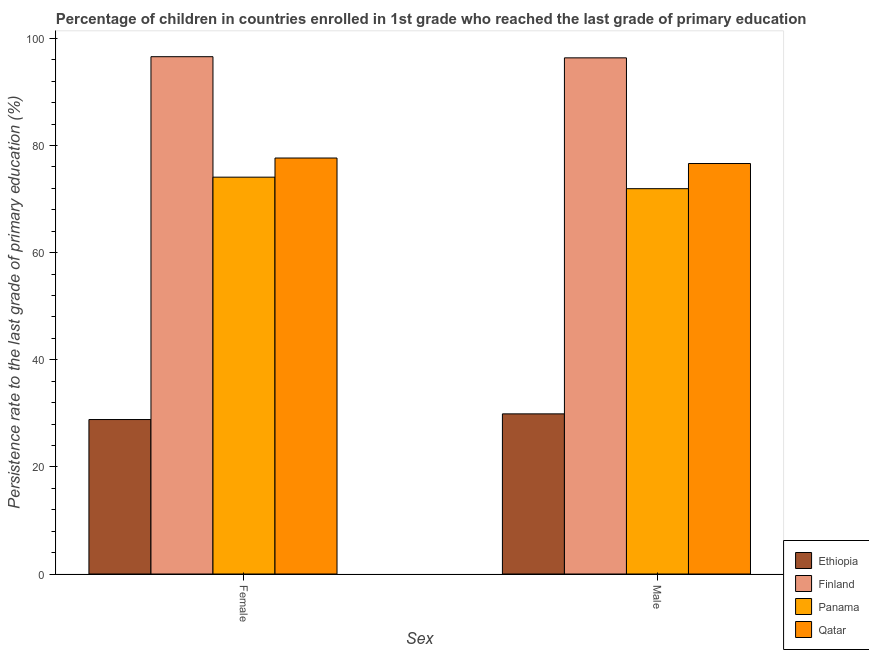Are the number of bars per tick equal to the number of legend labels?
Offer a very short reply. Yes. Are the number of bars on each tick of the X-axis equal?
Your answer should be compact. Yes. What is the label of the 2nd group of bars from the left?
Keep it short and to the point. Male. What is the persistence rate of female students in Finland?
Your answer should be compact. 96.59. Across all countries, what is the maximum persistence rate of female students?
Your answer should be very brief. 96.59. Across all countries, what is the minimum persistence rate of male students?
Offer a very short reply. 29.9. In which country was the persistence rate of male students maximum?
Offer a terse response. Finland. In which country was the persistence rate of male students minimum?
Your response must be concise. Ethiopia. What is the total persistence rate of female students in the graph?
Provide a short and direct response. 277.21. What is the difference between the persistence rate of male students in Panama and that in Ethiopia?
Provide a short and direct response. 42.05. What is the difference between the persistence rate of female students in Finland and the persistence rate of male students in Qatar?
Offer a terse response. 19.95. What is the average persistence rate of female students per country?
Provide a short and direct response. 69.3. What is the difference between the persistence rate of male students and persistence rate of female students in Panama?
Offer a terse response. -2.15. What is the ratio of the persistence rate of female students in Panama to that in Finland?
Offer a very short reply. 0.77. What does the 4th bar from the left in Male represents?
Offer a very short reply. Qatar. What does the 1st bar from the right in Female represents?
Offer a very short reply. Qatar. How many bars are there?
Offer a very short reply. 8. What is the difference between two consecutive major ticks on the Y-axis?
Give a very brief answer. 20. Where does the legend appear in the graph?
Keep it short and to the point. Bottom right. What is the title of the graph?
Keep it short and to the point. Percentage of children in countries enrolled in 1st grade who reached the last grade of primary education. Does "Least developed countries" appear as one of the legend labels in the graph?
Keep it short and to the point. No. What is the label or title of the X-axis?
Ensure brevity in your answer.  Sex. What is the label or title of the Y-axis?
Make the answer very short. Persistence rate to the last grade of primary education (%). What is the Persistence rate to the last grade of primary education (%) of Ethiopia in Female?
Your response must be concise. 28.84. What is the Persistence rate to the last grade of primary education (%) in Finland in Female?
Offer a very short reply. 96.59. What is the Persistence rate to the last grade of primary education (%) of Panama in Female?
Your response must be concise. 74.1. What is the Persistence rate to the last grade of primary education (%) of Qatar in Female?
Your answer should be very brief. 77.67. What is the Persistence rate to the last grade of primary education (%) of Ethiopia in Male?
Provide a short and direct response. 29.9. What is the Persistence rate to the last grade of primary education (%) of Finland in Male?
Your answer should be compact. 96.38. What is the Persistence rate to the last grade of primary education (%) in Panama in Male?
Ensure brevity in your answer.  71.95. What is the Persistence rate to the last grade of primary education (%) in Qatar in Male?
Your answer should be very brief. 76.65. Across all Sex, what is the maximum Persistence rate to the last grade of primary education (%) in Ethiopia?
Keep it short and to the point. 29.9. Across all Sex, what is the maximum Persistence rate to the last grade of primary education (%) in Finland?
Offer a terse response. 96.59. Across all Sex, what is the maximum Persistence rate to the last grade of primary education (%) in Panama?
Provide a short and direct response. 74.1. Across all Sex, what is the maximum Persistence rate to the last grade of primary education (%) in Qatar?
Provide a succinct answer. 77.67. Across all Sex, what is the minimum Persistence rate to the last grade of primary education (%) in Ethiopia?
Offer a terse response. 28.84. Across all Sex, what is the minimum Persistence rate to the last grade of primary education (%) in Finland?
Your answer should be very brief. 96.38. Across all Sex, what is the minimum Persistence rate to the last grade of primary education (%) of Panama?
Provide a succinct answer. 71.95. Across all Sex, what is the minimum Persistence rate to the last grade of primary education (%) of Qatar?
Provide a succinct answer. 76.65. What is the total Persistence rate to the last grade of primary education (%) in Ethiopia in the graph?
Provide a succinct answer. 58.74. What is the total Persistence rate to the last grade of primary education (%) in Finland in the graph?
Your response must be concise. 192.97. What is the total Persistence rate to the last grade of primary education (%) in Panama in the graph?
Give a very brief answer. 146.05. What is the total Persistence rate to the last grade of primary education (%) in Qatar in the graph?
Ensure brevity in your answer.  154.32. What is the difference between the Persistence rate to the last grade of primary education (%) of Ethiopia in Female and that in Male?
Provide a succinct answer. -1.06. What is the difference between the Persistence rate to the last grade of primary education (%) of Finland in Female and that in Male?
Make the answer very short. 0.22. What is the difference between the Persistence rate to the last grade of primary education (%) of Panama in Female and that in Male?
Make the answer very short. 2.15. What is the difference between the Persistence rate to the last grade of primary education (%) of Ethiopia in Female and the Persistence rate to the last grade of primary education (%) of Finland in Male?
Your response must be concise. -67.53. What is the difference between the Persistence rate to the last grade of primary education (%) in Ethiopia in Female and the Persistence rate to the last grade of primary education (%) in Panama in Male?
Your answer should be very brief. -43.11. What is the difference between the Persistence rate to the last grade of primary education (%) of Ethiopia in Female and the Persistence rate to the last grade of primary education (%) of Qatar in Male?
Offer a very short reply. -47.8. What is the difference between the Persistence rate to the last grade of primary education (%) in Finland in Female and the Persistence rate to the last grade of primary education (%) in Panama in Male?
Offer a terse response. 24.65. What is the difference between the Persistence rate to the last grade of primary education (%) of Finland in Female and the Persistence rate to the last grade of primary education (%) of Qatar in Male?
Offer a very short reply. 19.95. What is the difference between the Persistence rate to the last grade of primary education (%) in Panama in Female and the Persistence rate to the last grade of primary education (%) in Qatar in Male?
Your answer should be compact. -2.55. What is the average Persistence rate to the last grade of primary education (%) of Ethiopia per Sex?
Ensure brevity in your answer.  29.37. What is the average Persistence rate to the last grade of primary education (%) in Finland per Sex?
Your response must be concise. 96.49. What is the average Persistence rate to the last grade of primary education (%) in Panama per Sex?
Your answer should be compact. 73.02. What is the average Persistence rate to the last grade of primary education (%) of Qatar per Sex?
Give a very brief answer. 77.16. What is the difference between the Persistence rate to the last grade of primary education (%) of Ethiopia and Persistence rate to the last grade of primary education (%) of Finland in Female?
Offer a very short reply. -67.75. What is the difference between the Persistence rate to the last grade of primary education (%) of Ethiopia and Persistence rate to the last grade of primary education (%) of Panama in Female?
Give a very brief answer. -45.26. What is the difference between the Persistence rate to the last grade of primary education (%) in Ethiopia and Persistence rate to the last grade of primary education (%) in Qatar in Female?
Provide a short and direct response. -48.83. What is the difference between the Persistence rate to the last grade of primary education (%) in Finland and Persistence rate to the last grade of primary education (%) in Panama in Female?
Your response must be concise. 22.5. What is the difference between the Persistence rate to the last grade of primary education (%) of Finland and Persistence rate to the last grade of primary education (%) of Qatar in Female?
Make the answer very short. 18.92. What is the difference between the Persistence rate to the last grade of primary education (%) in Panama and Persistence rate to the last grade of primary education (%) in Qatar in Female?
Your response must be concise. -3.58. What is the difference between the Persistence rate to the last grade of primary education (%) of Ethiopia and Persistence rate to the last grade of primary education (%) of Finland in Male?
Provide a short and direct response. -66.48. What is the difference between the Persistence rate to the last grade of primary education (%) in Ethiopia and Persistence rate to the last grade of primary education (%) in Panama in Male?
Provide a succinct answer. -42.05. What is the difference between the Persistence rate to the last grade of primary education (%) in Ethiopia and Persistence rate to the last grade of primary education (%) in Qatar in Male?
Keep it short and to the point. -46.75. What is the difference between the Persistence rate to the last grade of primary education (%) in Finland and Persistence rate to the last grade of primary education (%) in Panama in Male?
Offer a very short reply. 24.43. What is the difference between the Persistence rate to the last grade of primary education (%) in Finland and Persistence rate to the last grade of primary education (%) in Qatar in Male?
Ensure brevity in your answer.  19.73. What is the difference between the Persistence rate to the last grade of primary education (%) in Panama and Persistence rate to the last grade of primary education (%) in Qatar in Male?
Your answer should be compact. -4.7. What is the ratio of the Persistence rate to the last grade of primary education (%) in Ethiopia in Female to that in Male?
Keep it short and to the point. 0.96. What is the ratio of the Persistence rate to the last grade of primary education (%) in Finland in Female to that in Male?
Provide a short and direct response. 1. What is the ratio of the Persistence rate to the last grade of primary education (%) in Panama in Female to that in Male?
Your answer should be compact. 1.03. What is the ratio of the Persistence rate to the last grade of primary education (%) of Qatar in Female to that in Male?
Offer a very short reply. 1.01. What is the difference between the highest and the second highest Persistence rate to the last grade of primary education (%) in Ethiopia?
Offer a terse response. 1.06. What is the difference between the highest and the second highest Persistence rate to the last grade of primary education (%) of Finland?
Your answer should be compact. 0.22. What is the difference between the highest and the second highest Persistence rate to the last grade of primary education (%) in Panama?
Provide a succinct answer. 2.15. What is the difference between the highest and the lowest Persistence rate to the last grade of primary education (%) of Ethiopia?
Offer a very short reply. 1.06. What is the difference between the highest and the lowest Persistence rate to the last grade of primary education (%) of Finland?
Provide a succinct answer. 0.22. What is the difference between the highest and the lowest Persistence rate to the last grade of primary education (%) of Panama?
Offer a terse response. 2.15. What is the difference between the highest and the lowest Persistence rate to the last grade of primary education (%) of Qatar?
Provide a succinct answer. 1.03. 